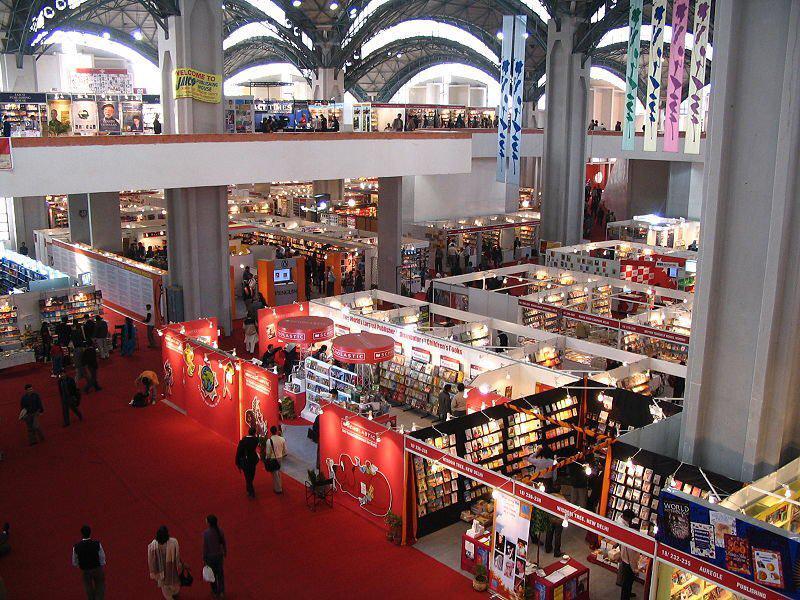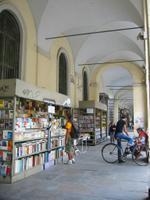The first image is the image on the left, the second image is the image on the right. Given the left and right images, does the statement "The sky is partially visible behind a book stall in the right image." hold true? Answer yes or no. No. The first image is the image on the left, the second image is the image on the right. Given the left and right images, does the statement "A vehicle is parked in the area near the sales in the image on the right." hold true? Answer yes or no. Yes. 